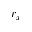Convert formula to latex. <formula><loc_0><loc_0><loc_500><loc_500>r _ { x }</formula> 